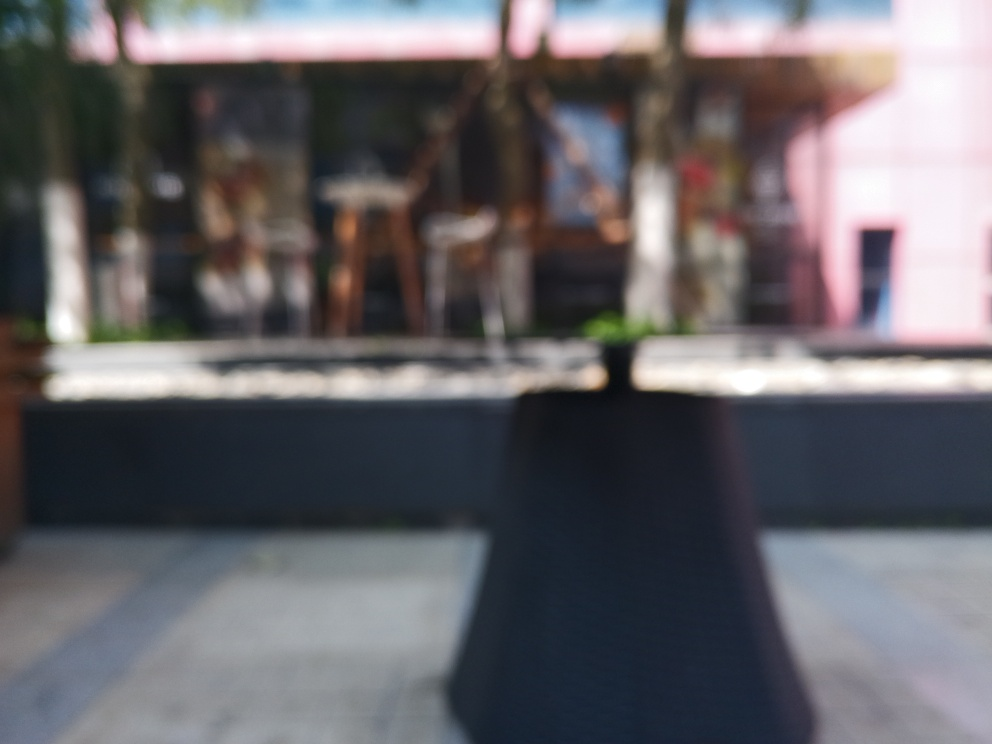Is the clarity of the image extremely poor? Based on the image, it appears that the focus is significantly off, resulting in a highly blurred scene that lacks sharpness and detail. Such lack of clarity often obscures important characteristics of the subjects within the photo, making it difficult to discern specific elements or assess the true nature of the scene. 